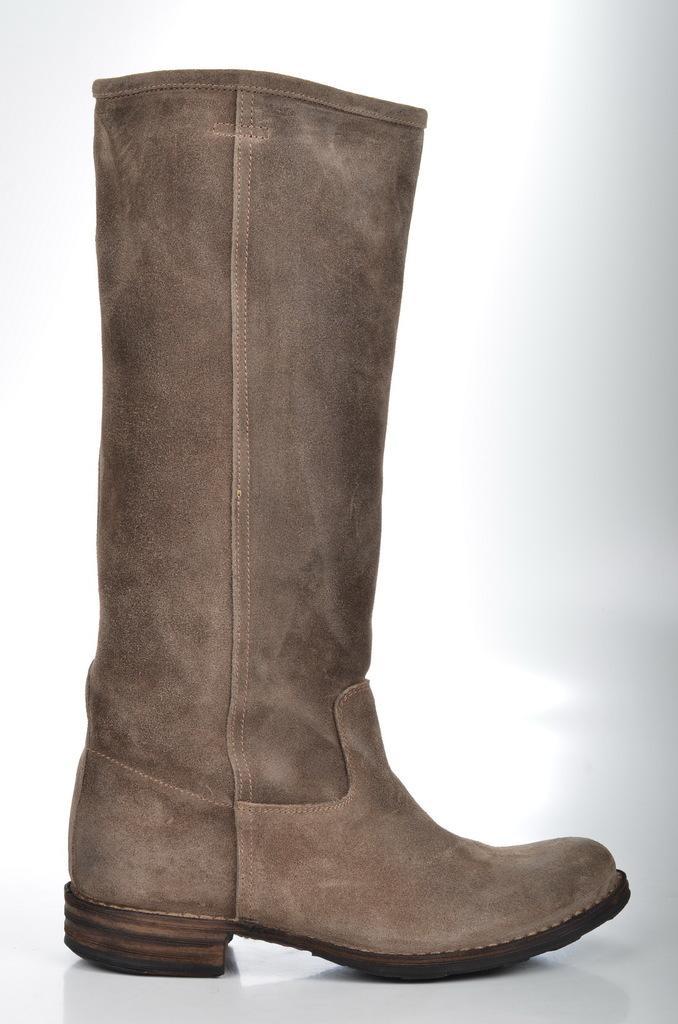Could you give a brief overview of what you see in this image? In this image I can see a brown colour boot. I can also see white colour in background. 